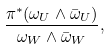<formula> <loc_0><loc_0><loc_500><loc_500>\frac { \pi ^ { * } ( \omega _ { U } \wedge \bar { \omega } _ { U } ) } { \omega _ { W } \wedge \bar { \omega } _ { W } } ,</formula> 